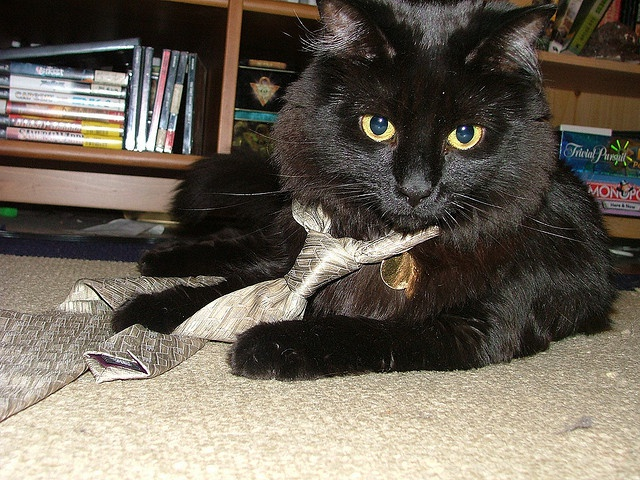Describe the objects in this image and their specific colors. I can see cat in black and gray tones, tie in black, darkgray, ivory, and gray tones, book in black, lightgray, gray, and darkgray tones, book in black, gray, darkgray, and purple tones, and book in black, white, darkgray, and gray tones in this image. 